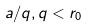<formula> <loc_0><loc_0><loc_500><loc_500>a / q , q < r _ { 0 }</formula> 